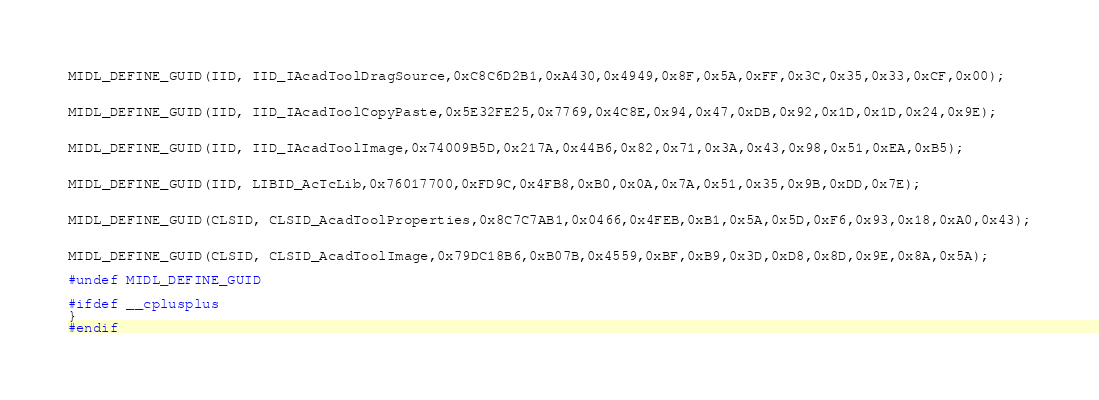Convert code to text. <code><loc_0><loc_0><loc_500><loc_500><_C_>

MIDL_DEFINE_GUID(IID, IID_IAcadToolDragSource,0xC8C6D2B1,0xA430,0x4949,0x8F,0x5A,0xFF,0x3C,0x35,0x33,0xCF,0x00);


MIDL_DEFINE_GUID(IID, IID_IAcadToolCopyPaste,0x5E32FE25,0x7769,0x4C8E,0x94,0x47,0xDB,0x92,0x1D,0x1D,0x24,0x9E);


MIDL_DEFINE_GUID(IID, IID_IAcadToolImage,0x74009B5D,0x217A,0x44B6,0x82,0x71,0x3A,0x43,0x98,0x51,0xEA,0xB5);


MIDL_DEFINE_GUID(IID, LIBID_AcTcLib,0x76017700,0xFD9C,0x4FB8,0xB0,0x0A,0x7A,0x51,0x35,0x9B,0xDD,0x7E);


MIDL_DEFINE_GUID(CLSID, CLSID_AcadToolProperties,0x8C7C7AB1,0x0466,0x4FEB,0xB1,0x5A,0x5D,0xF6,0x93,0x18,0xA0,0x43);


MIDL_DEFINE_GUID(CLSID, CLSID_AcadToolImage,0x79DC18B6,0xB07B,0x4559,0xBF,0xB9,0x3D,0xD8,0x8D,0x9E,0x8A,0x5A);

#undef MIDL_DEFINE_GUID

#ifdef __cplusplus
}
#endif



</code> 